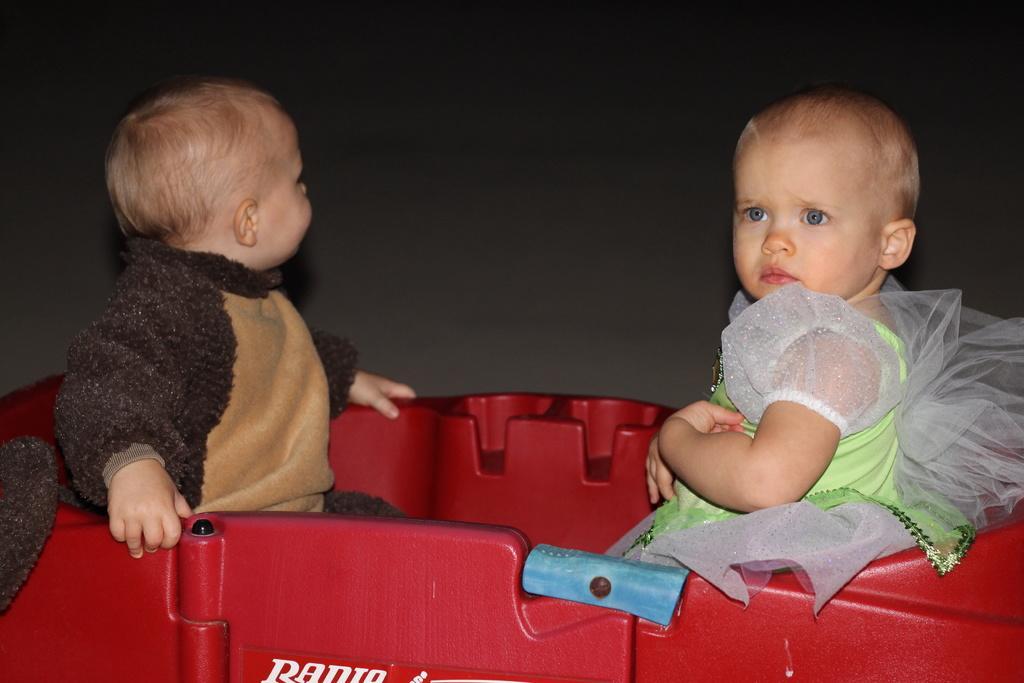Could you give a brief overview of what you see in this image? In the center of the image there are two kids sitting. In the background of the image there is wall. 